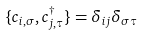<formula> <loc_0><loc_0><loc_500><loc_500>\{ c _ { i , \sigma } , c _ { j , \tau } ^ { \dagger } \} = \delta _ { i j } \delta _ { \sigma \tau }</formula> 